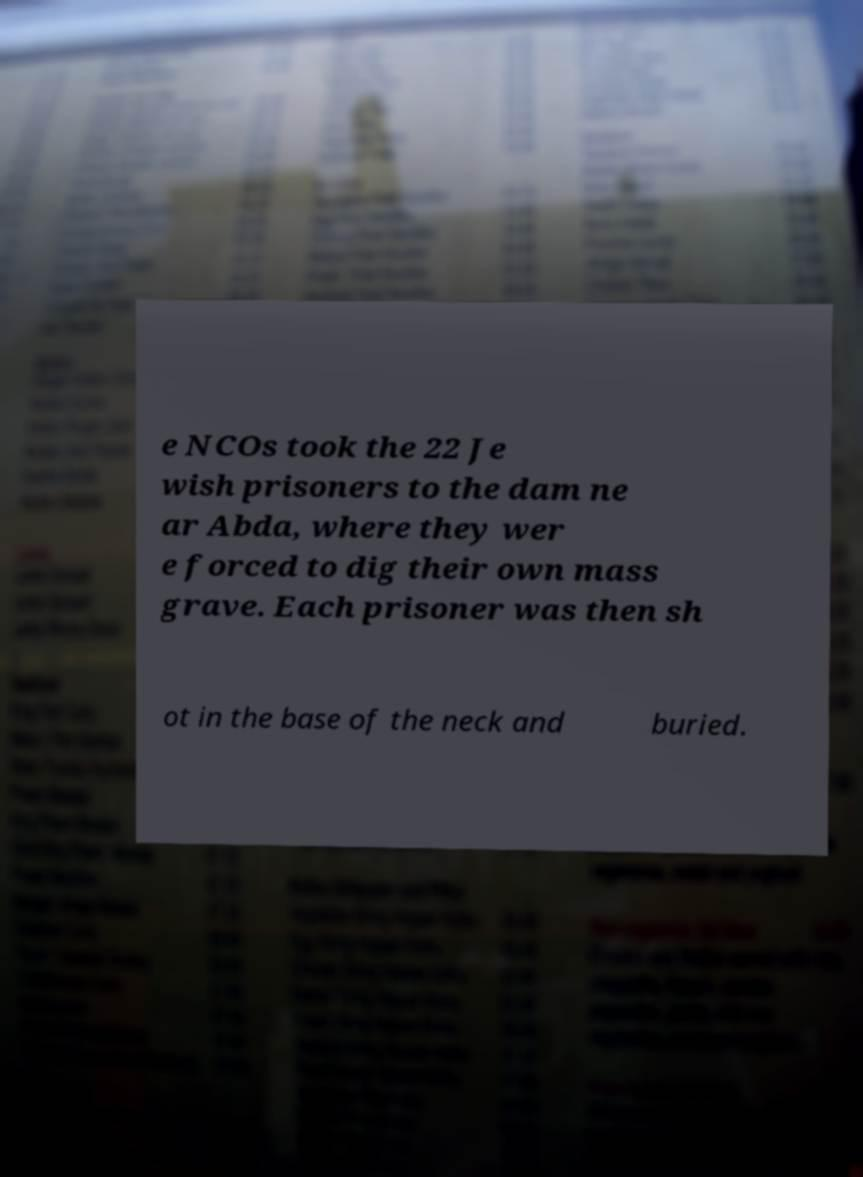I need the written content from this picture converted into text. Can you do that? e NCOs took the 22 Je wish prisoners to the dam ne ar Abda, where they wer e forced to dig their own mass grave. Each prisoner was then sh ot in the base of the neck and buried. 